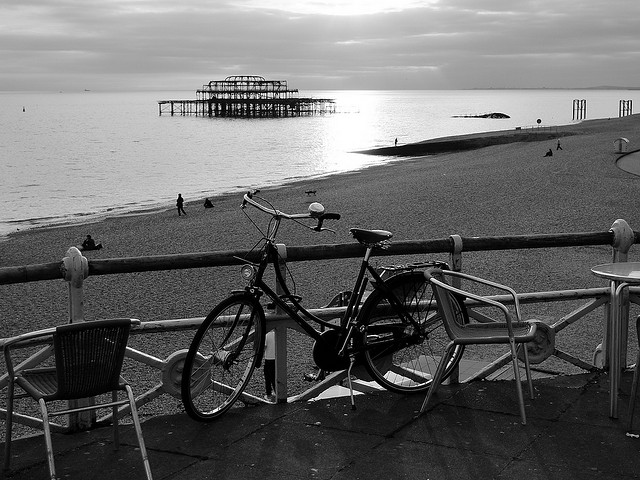<image>What company make's the bike? I don't know which company makes the bike, it could be Schwinn, Ford, Murphy, Suzuki, Peugeot, or Huffy. What company make's the bike? I am not sure what company makes the bike. It can be either Schwinn, Ford, Murphy, Suzuki, Peugeot, or Huffy. 